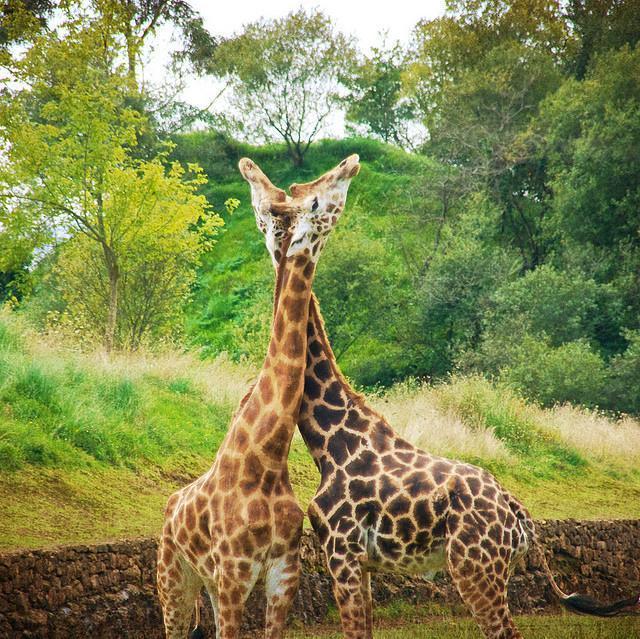How many giraffes are there?
Give a very brief answer. 2. 